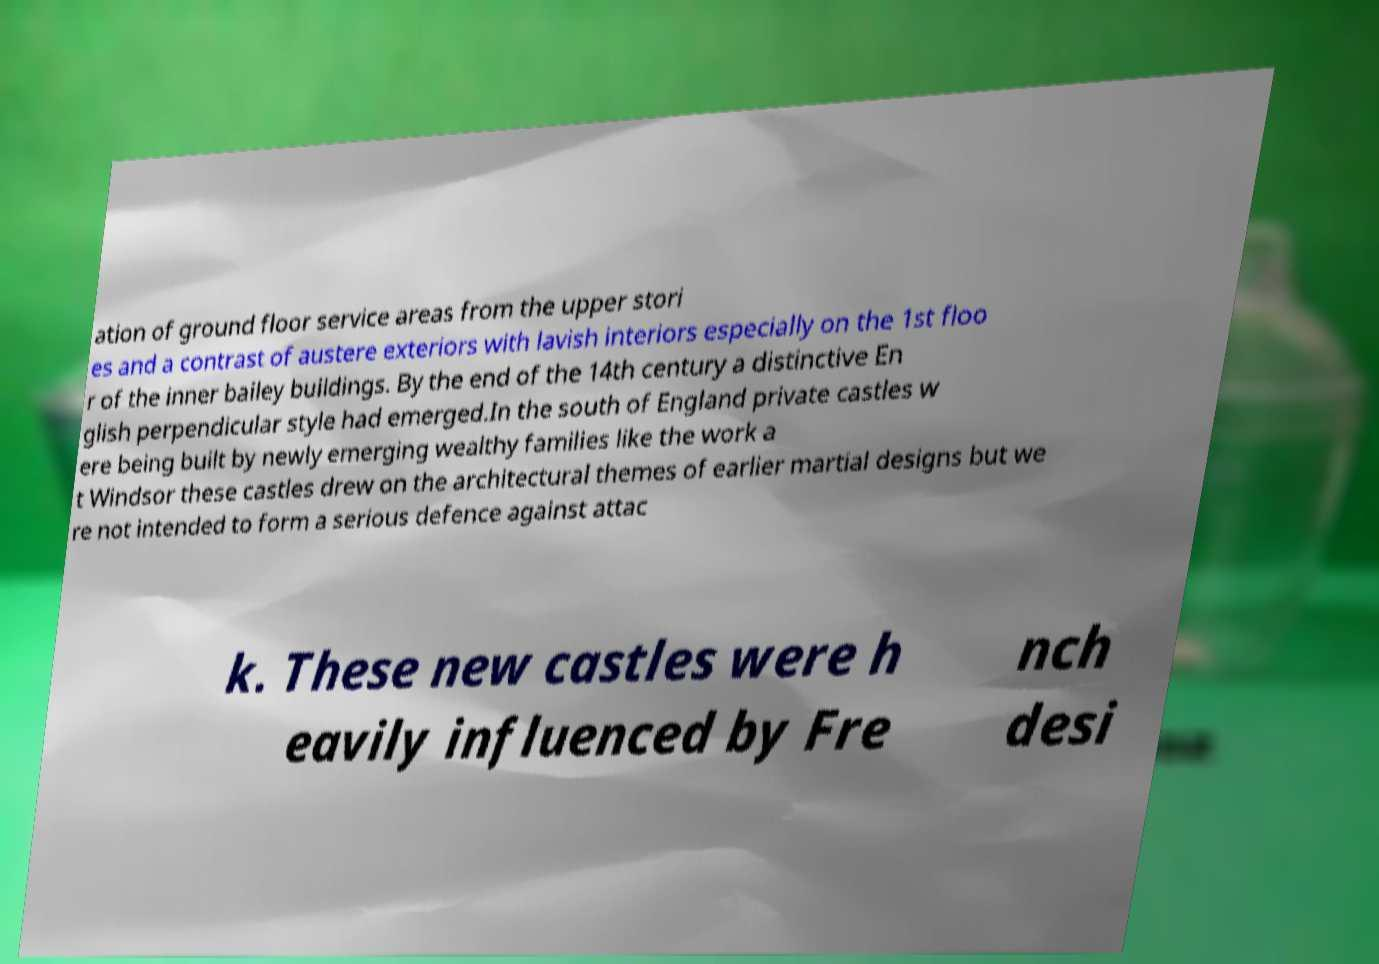For documentation purposes, I need the text within this image transcribed. Could you provide that? ation of ground floor service areas from the upper stori es and a contrast of austere exteriors with lavish interiors especially on the 1st floo r of the inner bailey buildings. By the end of the 14th century a distinctive En glish perpendicular style had emerged.In the south of England private castles w ere being built by newly emerging wealthy families like the work a t Windsor these castles drew on the architectural themes of earlier martial designs but we re not intended to form a serious defence against attac k. These new castles were h eavily influenced by Fre nch desi 